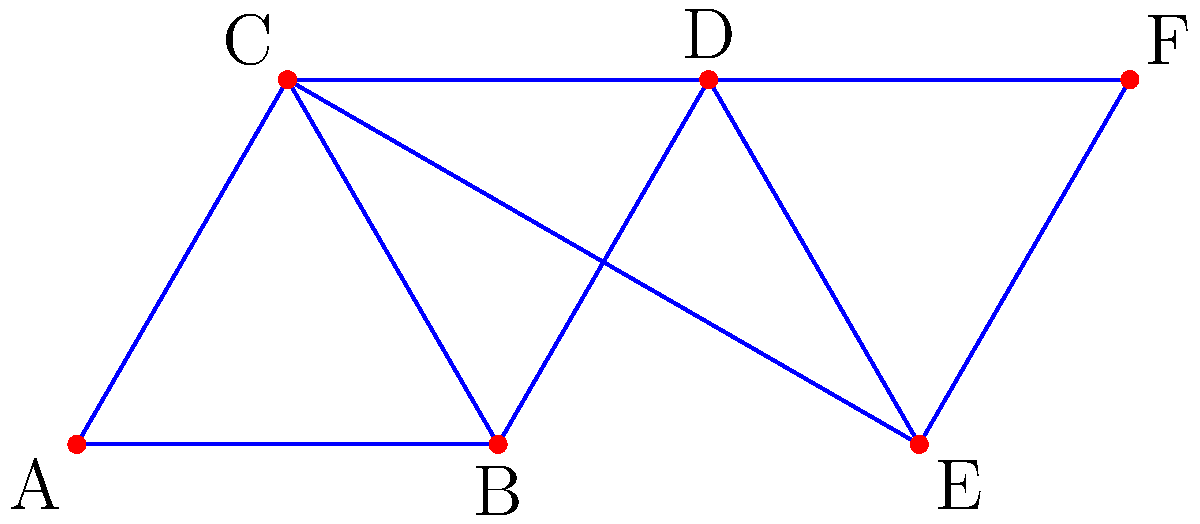Given the network of potential radar station locations represented by the graph above, where each vertex represents a possible location and each edge represents a direct line of sight between locations, what is the minimum number of radar stations required to cover all edges (lines of sight) in the network? To solve this problem, we need to find the minimum vertex cover of the given graph. A vertex cover is a set of vertices such that each edge of the graph is incident to at least one vertex in the set. The steps to find the solution are:

1. Observe that the graph is composed of two overlapping triangles (ABC and DEF) connected by edges BD and CE.

2. In any triangle, we need at least two vertices to cover all edges. This is because if we choose only one vertex, the edge opposite to it will not be covered.

3. For triangle ABC:
   - We need at least 2 vertices from A, B, and C.

4. For triangle DEF:
   - We need at least 2 vertices from D, E, and F.

5. Now, we need to check if these selections can also cover the connecting edges BD and CE:
   - If we choose B and D from the respective triangles, both connecting edges will be covered.
   - Alternatively, if we choose C and E, both connecting edges will also be covered.

6. Therefore, the minimum number of vertices needed to cover all edges is 4.

This solution ensures that all lines of sight (edges) in the network are covered by at least one radar station, providing maximum coverage with the minimum number of stations.
Answer: 4 radar stations 